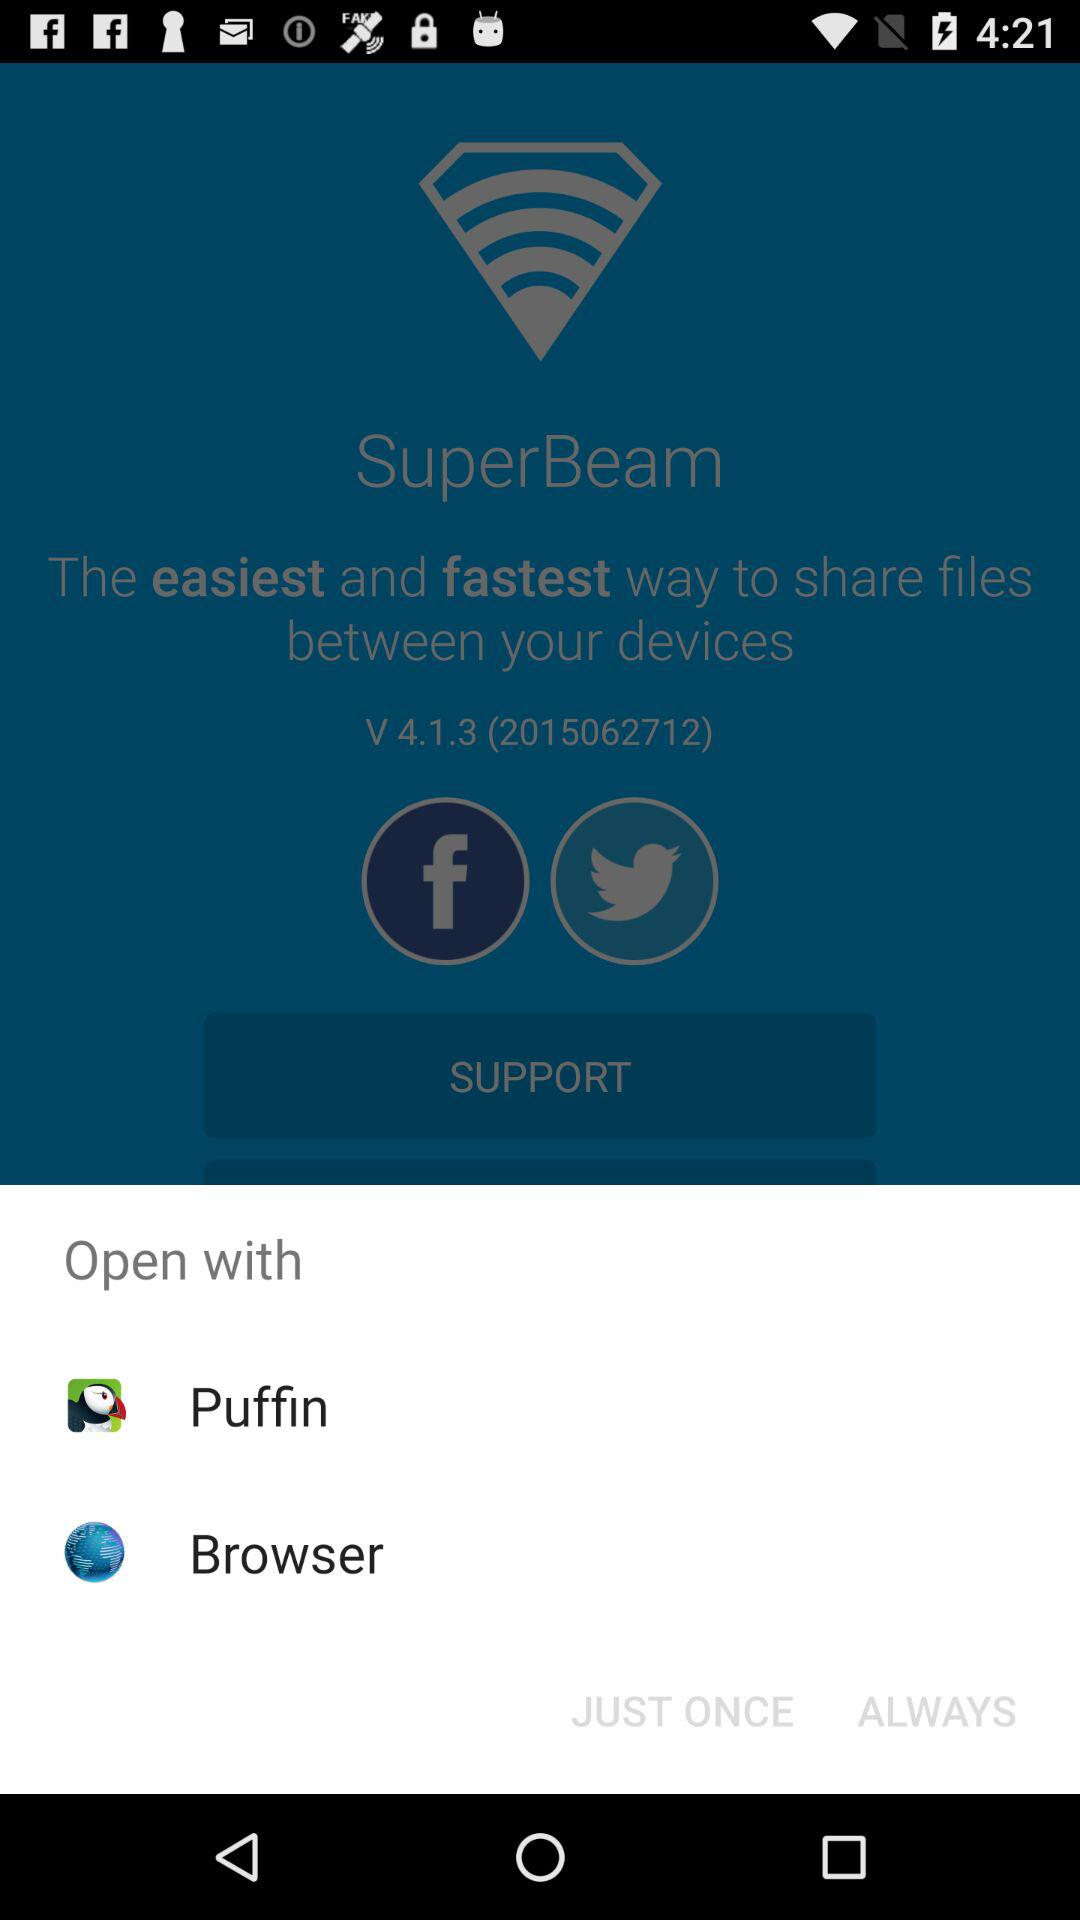Who is opening the "SuperBeam" application?
When the provided information is insufficient, respond with <no answer>. <no answer> 